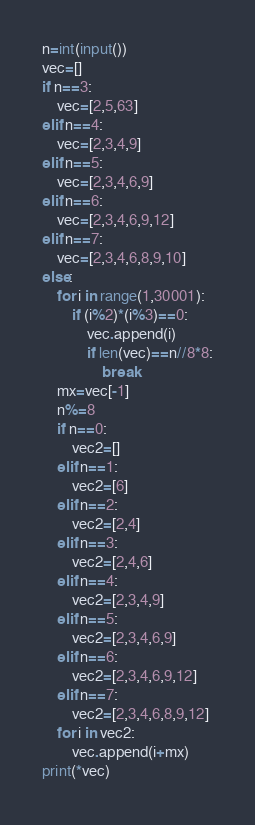Convert code to text. <code><loc_0><loc_0><loc_500><loc_500><_Python_>n=int(input())
vec=[]
if n==3:
    vec=[2,5,63]
elif n==4:
    vec=[2,3,4,9]
elif n==5:
    vec=[2,3,4,6,9]
elif n==6:
    vec=[2,3,4,6,9,12]
elif n==7:
    vec=[2,3,4,6,8,9,10]
else:
    for i in range(1,30001):
        if (i%2)*(i%3)==0:
            vec.append(i)
            if len(vec)==n//8*8:
                break
    mx=vec[-1]
    n%=8
    if n==0:
        vec2=[]
    elif n==1:
        vec2=[6]
    elif n==2:
        vec2=[2,4]
    elif n==3:
        vec2=[2,4,6]
    elif n==4:
        vec2=[2,3,4,9]
    elif n==5:
        vec2=[2,3,4,6,9]
    elif n==6:
        vec2=[2,3,4,6,9,12]
    elif n==7:
        vec2=[2,3,4,6,8,9,12]
    for i in vec2:
        vec.append(i+mx)
print(*vec)</code> 